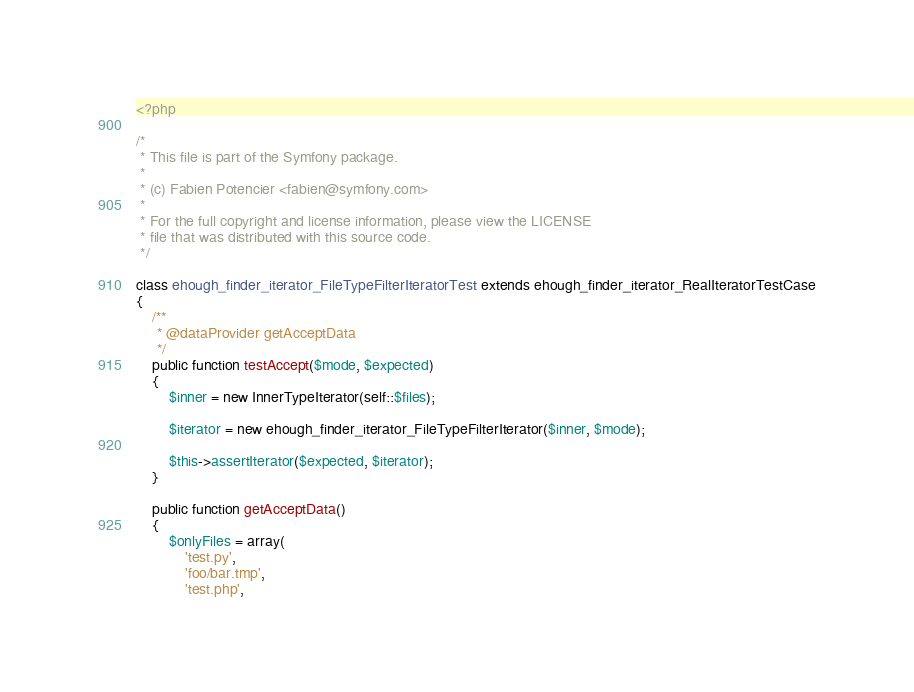Convert code to text. <code><loc_0><loc_0><loc_500><loc_500><_PHP_><?php

/*
 * This file is part of the Symfony package.
 *
 * (c) Fabien Potencier <fabien@symfony.com>
 *
 * For the full copyright and license information, please view the LICENSE
 * file that was distributed with this source code.
 */

class ehough_finder_iterator_FileTypeFilterIteratorTest extends ehough_finder_iterator_RealIteratorTestCase
{
    /**
     * @dataProvider getAcceptData
     */
    public function testAccept($mode, $expected)
    {
        $inner = new InnerTypeIterator(self::$files);

        $iterator = new ehough_finder_iterator_FileTypeFilterIterator($inner, $mode);

        $this->assertIterator($expected, $iterator);
    }

    public function getAcceptData()
    {
        $onlyFiles = array(
            'test.py',
            'foo/bar.tmp',
            'test.php',</code> 